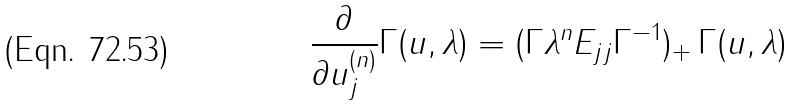<formula> <loc_0><loc_0><loc_500><loc_500>\frac { \partial } { \partial u _ { j } ^ { ( n ) } } \Gamma ( { u } , \lambda ) = ( \Gamma \lambda ^ { n } E _ { j j } { \Gamma } ^ { - 1 } ) _ { + } \, \Gamma ( { u } , \lambda )</formula> 